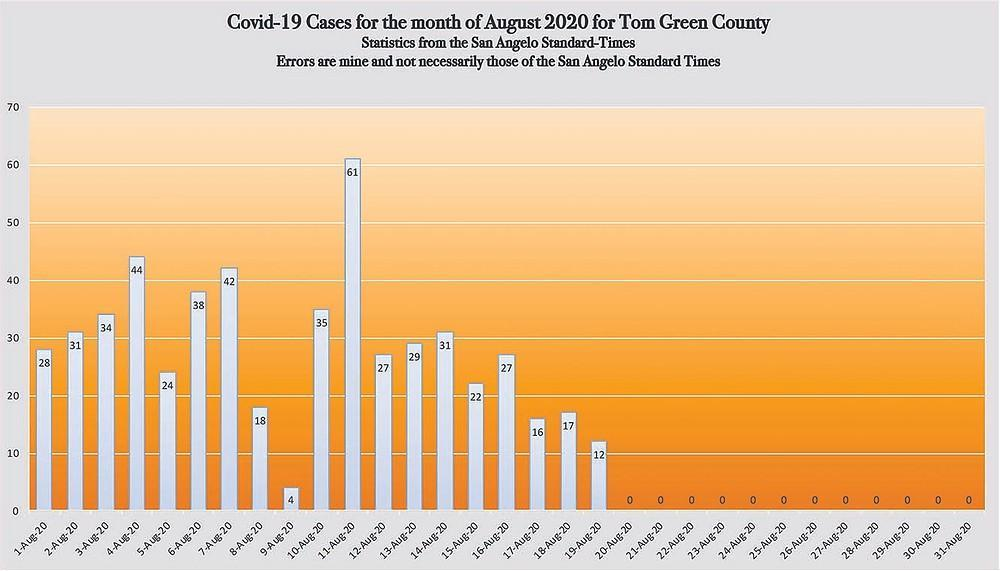In how many days the number of case is between 36 and 45
Answer the question with a short phrase. 3 In how many days the number of cases is greater than 40? 3 In how many days the number of cases is less than 30? 11 